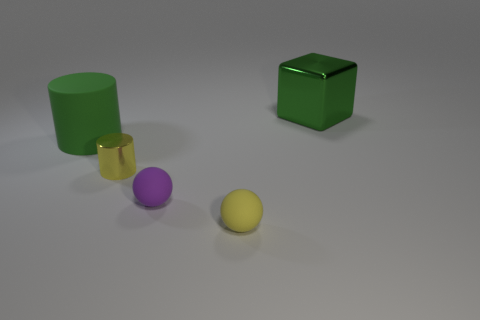Add 4 purple matte spheres. How many objects exist? 9 Subtract all balls. How many objects are left? 3 Add 2 small gray cubes. How many small gray cubes exist? 2 Subtract 0 gray spheres. How many objects are left? 5 Subtract all small cylinders. Subtract all large green cylinders. How many objects are left? 3 Add 5 rubber balls. How many rubber balls are left? 7 